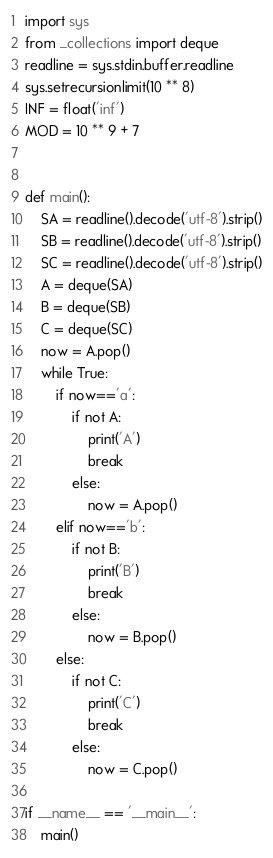<code> <loc_0><loc_0><loc_500><loc_500><_Python_>import sys
from _collections import deque
readline = sys.stdin.buffer.readline
sys.setrecursionlimit(10 ** 8)
INF = float('inf')
MOD = 10 ** 9 + 7


def main():
    SA = readline().decode('utf-8').strip()
    SB = readline().decode('utf-8').strip()
    SC = readline().decode('utf-8').strip()
    A = deque(SA)
    B = deque(SB)
    C = deque(SC)
    now = A.pop()
    while True:
        if now=='a':
            if not A:
                print('A')
                break
            else:
                now = A.pop()
        elif now=='b':
            if not B:
                print('B')
                break
            else:
                now = B.pop()
        else:
            if not C:
                print('C')
                break
            else:
                now = C.pop()

if __name__ == '__main__':
    main()</code> 